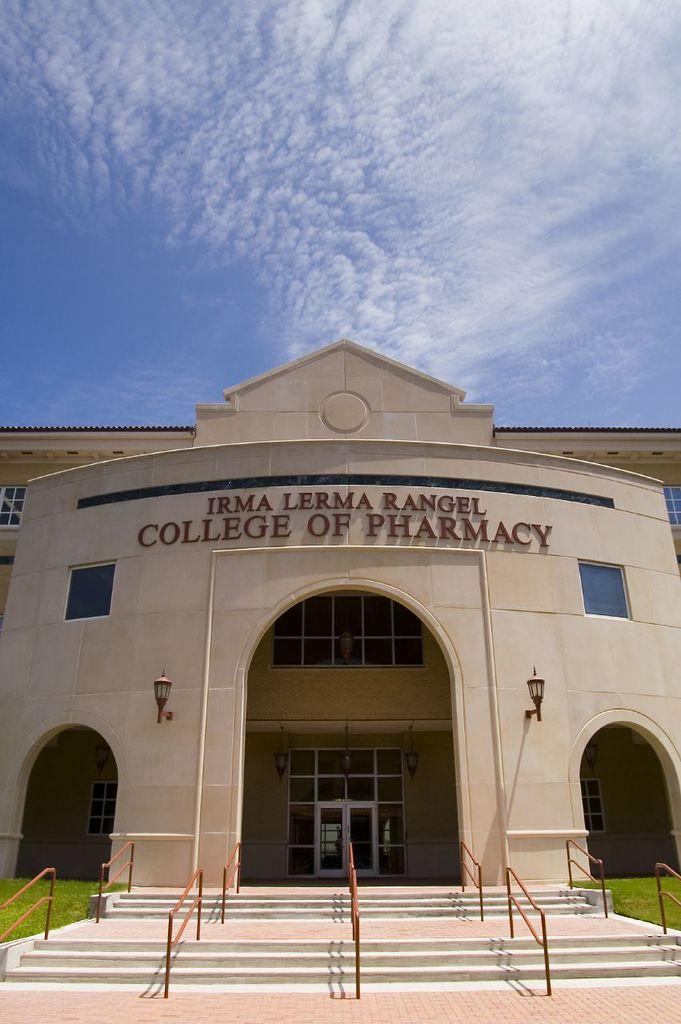What type of structure is visible in the image? There is a building in the image. What can be used to enter or exit the building? There is a door in the image. How can natural light enter the building? There are windows in the image. What provides illumination in the building? There are lights in the image. What can be used for support or assistance while navigating the building? There are handrails in the image. How can people move between different levels of the building? There are staircases in the image. What type of vegetation is present near the building? There is grass in the image. What can be seen above the building? The sky is visible in the image. Is there any text or signage on the building? Yes, there is text on the building. What type of bait is being used to catch fish in the image? There is no fishing or bait present in the image; it features a building with various architectural elements and natural surroundings. 